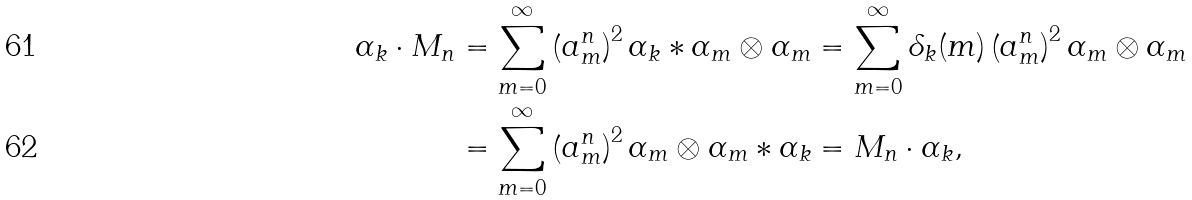<formula> <loc_0><loc_0><loc_500><loc_500>\alpha _ { k } \cdot M _ { n } & = \sum _ { m = 0 } ^ { \infty } \left ( a _ { m } ^ { n } \right ) ^ { 2 } \alpha _ { k } \ast \alpha _ { m } \otimes \alpha _ { m } = \sum _ { m = 0 } ^ { \infty } \delta _ { k } ( m ) \left ( a _ { m } ^ { n } \right ) ^ { 2 } \alpha _ { m } \otimes \alpha _ { m } \\ & = \sum _ { m = 0 } ^ { \infty } \left ( a _ { m } ^ { n } \right ) ^ { 2 } \alpha _ { m } \otimes \alpha _ { m } \ast \alpha _ { k } = M _ { n } \cdot \alpha _ { k } ,</formula> 